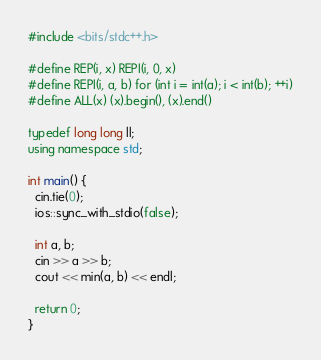<code> <loc_0><loc_0><loc_500><loc_500><_C++_>#include <bits/stdc++.h>

#define REP(i, x) REPI(i, 0, x)
#define REPI(i, a, b) for (int i = int(a); i < int(b); ++i)
#define ALL(x) (x).begin(), (x).end()

typedef long long ll;
using namespace std;

int main() {
  cin.tie(0);
  ios::sync_with_stdio(false);

  int a, b;
  cin >> a >> b;
  cout << min(a, b) << endl;

  return 0;
}
</code> 